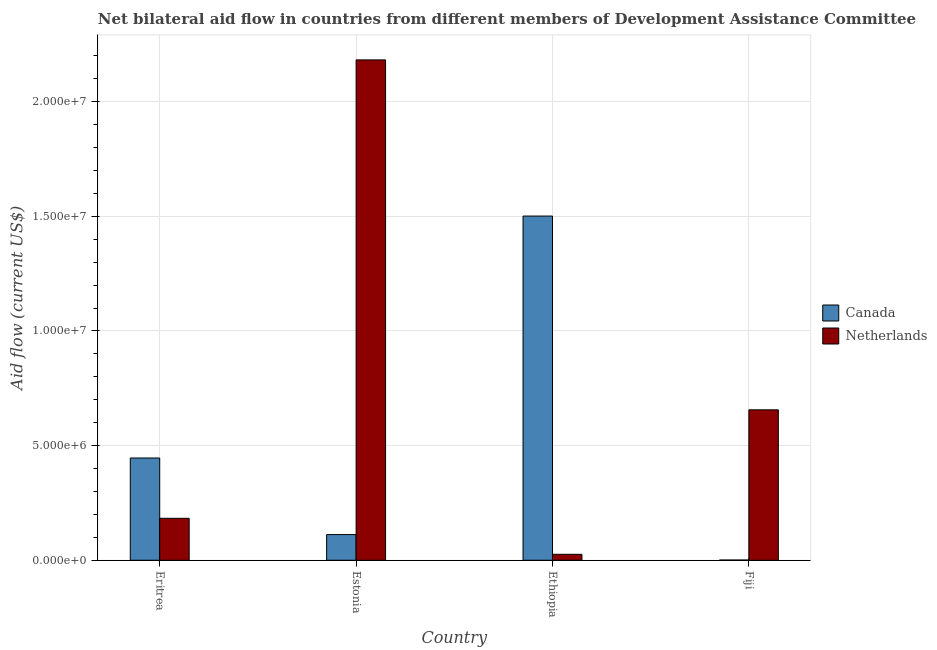How many different coloured bars are there?
Provide a succinct answer. 2. Are the number of bars per tick equal to the number of legend labels?
Your answer should be compact. Yes. How many bars are there on the 2nd tick from the left?
Your response must be concise. 2. How many bars are there on the 4th tick from the right?
Your answer should be very brief. 2. What is the label of the 4th group of bars from the left?
Keep it short and to the point. Fiji. What is the amount of aid given by netherlands in Ethiopia?
Keep it short and to the point. 2.60e+05. Across all countries, what is the maximum amount of aid given by canada?
Offer a terse response. 1.50e+07. Across all countries, what is the minimum amount of aid given by canada?
Your answer should be very brief. 10000. In which country was the amount of aid given by netherlands maximum?
Make the answer very short. Estonia. In which country was the amount of aid given by netherlands minimum?
Provide a succinct answer. Ethiopia. What is the total amount of aid given by netherlands in the graph?
Your answer should be very brief. 3.05e+07. What is the difference between the amount of aid given by netherlands in Estonia and that in Ethiopia?
Ensure brevity in your answer.  2.16e+07. What is the difference between the amount of aid given by netherlands in Estonia and the amount of aid given by canada in Eritrea?
Give a very brief answer. 1.74e+07. What is the average amount of aid given by canada per country?
Your answer should be very brief. 5.15e+06. What is the difference between the amount of aid given by canada and amount of aid given by netherlands in Ethiopia?
Ensure brevity in your answer.  1.48e+07. What is the ratio of the amount of aid given by netherlands in Estonia to that in Fiji?
Provide a short and direct response. 3.33. Is the amount of aid given by netherlands in Eritrea less than that in Ethiopia?
Your response must be concise. No. What is the difference between the highest and the second highest amount of aid given by canada?
Make the answer very short. 1.06e+07. What is the difference between the highest and the lowest amount of aid given by canada?
Provide a succinct answer. 1.50e+07. In how many countries, is the amount of aid given by canada greater than the average amount of aid given by canada taken over all countries?
Keep it short and to the point. 1. Is the sum of the amount of aid given by canada in Eritrea and Ethiopia greater than the maximum amount of aid given by netherlands across all countries?
Keep it short and to the point. No. What does the 1st bar from the left in Eritrea represents?
Offer a terse response. Canada. What does the 2nd bar from the right in Eritrea represents?
Your answer should be compact. Canada. How many bars are there?
Your answer should be very brief. 8. What is the difference between two consecutive major ticks on the Y-axis?
Ensure brevity in your answer.  5.00e+06. How many legend labels are there?
Make the answer very short. 2. How are the legend labels stacked?
Ensure brevity in your answer.  Vertical. What is the title of the graph?
Keep it short and to the point. Net bilateral aid flow in countries from different members of Development Assistance Committee. What is the label or title of the X-axis?
Keep it short and to the point. Country. What is the Aid flow (current US$) in Canada in Eritrea?
Provide a short and direct response. 4.46e+06. What is the Aid flow (current US$) of Netherlands in Eritrea?
Your answer should be compact. 1.83e+06. What is the Aid flow (current US$) of Canada in Estonia?
Your answer should be very brief. 1.12e+06. What is the Aid flow (current US$) of Netherlands in Estonia?
Your answer should be very brief. 2.18e+07. What is the Aid flow (current US$) in Canada in Ethiopia?
Offer a terse response. 1.50e+07. What is the Aid flow (current US$) in Netherlands in Ethiopia?
Your response must be concise. 2.60e+05. What is the Aid flow (current US$) of Netherlands in Fiji?
Your response must be concise. 6.56e+06. Across all countries, what is the maximum Aid flow (current US$) of Canada?
Make the answer very short. 1.50e+07. Across all countries, what is the maximum Aid flow (current US$) of Netherlands?
Provide a short and direct response. 2.18e+07. Across all countries, what is the minimum Aid flow (current US$) of Canada?
Keep it short and to the point. 10000. Across all countries, what is the minimum Aid flow (current US$) of Netherlands?
Provide a short and direct response. 2.60e+05. What is the total Aid flow (current US$) in Canada in the graph?
Your response must be concise. 2.06e+07. What is the total Aid flow (current US$) in Netherlands in the graph?
Offer a very short reply. 3.05e+07. What is the difference between the Aid flow (current US$) in Canada in Eritrea and that in Estonia?
Provide a short and direct response. 3.34e+06. What is the difference between the Aid flow (current US$) of Netherlands in Eritrea and that in Estonia?
Give a very brief answer. -2.00e+07. What is the difference between the Aid flow (current US$) in Canada in Eritrea and that in Ethiopia?
Keep it short and to the point. -1.06e+07. What is the difference between the Aid flow (current US$) of Netherlands in Eritrea and that in Ethiopia?
Offer a terse response. 1.57e+06. What is the difference between the Aid flow (current US$) in Canada in Eritrea and that in Fiji?
Keep it short and to the point. 4.45e+06. What is the difference between the Aid flow (current US$) in Netherlands in Eritrea and that in Fiji?
Give a very brief answer. -4.73e+06. What is the difference between the Aid flow (current US$) of Canada in Estonia and that in Ethiopia?
Your answer should be very brief. -1.39e+07. What is the difference between the Aid flow (current US$) in Netherlands in Estonia and that in Ethiopia?
Make the answer very short. 2.16e+07. What is the difference between the Aid flow (current US$) in Canada in Estonia and that in Fiji?
Keep it short and to the point. 1.11e+06. What is the difference between the Aid flow (current US$) of Netherlands in Estonia and that in Fiji?
Your answer should be compact. 1.53e+07. What is the difference between the Aid flow (current US$) of Canada in Ethiopia and that in Fiji?
Provide a short and direct response. 1.50e+07. What is the difference between the Aid flow (current US$) of Netherlands in Ethiopia and that in Fiji?
Offer a very short reply. -6.30e+06. What is the difference between the Aid flow (current US$) in Canada in Eritrea and the Aid flow (current US$) in Netherlands in Estonia?
Provide a short and direct response. -1.74e+07. What is the difference between the Aid flow (current US$) in Canada in Eritrea and the Aid flow (current US$) in Netherlands in Ethiopia?
Your answer should be compact. 4.20e+06. What is the difference between the Aid flow (current US$) in Canada in Eritrea and the Aid flow (current US$) in Netherlands in Fiji?
Offer a terse response. -2.10e+06. What is the difference between the Aid flow (current US$) of Canada in Estonia and the Aid flow (current US$) of Netherlands in Ethiopia?
Provide a succinct answer. 8.60e+05. What is the difference between the Aid flow (current US$) of Canada in Estonia and the Aid flow (current US$) of Netherlands in Fiji?
Your response must be concise. -5.44e+06. What is the difference between the Aid flow (current US$) of Canada in Ethiopia and the Aid flow (current US$) of Netherlands in Fiji?
Make the answer very short. 8.45e+06. What is the average Aid flow (current US$) of Canada per country?
Offer a terse response. 5.15e+06. What is the average Aid flow (current US$) of Netherlands per country?
Offer a very short reply. 7.62e+06. What is the difference between the Aid flow (current US$) in Canada and Aid flow (current US$) in Netherlands in Eritrea?
Your answer should be compact. 2.63e+06. What is the difference between the Aid flow (current US$) in Canada and Aid flow (current US$) in Netherlands in Estonia?
Your response must be concise. -2.07e+07. What is the difference between the Aid flow (current US$) in Canada and Aid flow (current US$) in Netherlands in Ethiopia?
Your answer should be compact. 1.48e+07. What is the difference between the Aid flow (current US$) in Canada and Aid flow (current US$) in Netherlands in Fiji?
Offer a very short reply. -6.55e+06. What is the ratio of the Aid flow (current US$) of Canada in Eritrea to that in Estonia?
Make the answer very short. 3.98. What is the ratio of the Aid flow (current US$) in Netherlands in Eritrea to that in Estonia?
Provide a succinct answer. 0.08. What is the ratio of the Aid flow (current US$) of Canada in Eritrea to that in Ethiopia?
Provide a succinct answer. 0.3. What is the ratio of the Aid flow (current US$) in Netherlands in Eritrea to that in Ethiopia?
Give a very brief answer. 7.04. What is the ratio of the Aid flow (current US$) in Canada in Eritrea to that in Fiji?
Your answer should be very brief. 446. What is the ratio of the Aid flow (current US$) in Netherlands in Eritrea to that in Fiji?
Offer a terse response. 0.28. What is the ratio of the Aid flow (current US$) of Canada in Estonia to that in Ethiopia?
Provide a succinct answer. 0.07. What is the ratio of the Aid flow (current US$) of Netherlands in Estonia to that in Ethiopia?
Ensure brevity in your answer.  83.92. What is the ratio of the Aid flow (current US$) of Canada in Estonia to that in Fiji?
Your response must be concise. 112. What is the ratio of the Aid flow (current US$) of Netherlands in Estonia to that in Fiji?
Give a very brief answer. 3.33. What is the ratio of the Aid flow (current US$) in Canada in Ethiopia to that in Fiji?
Provide a short and direct response. 1501. What is the ratio of the Aid flow (current US$) of Netherlands in Ethiopia to that in Fiji?
Your answer should be very brief. 0.04. What is the difference between the highest and the second highest Aid flow (current US$) in Canada?
Provide a succinct answer. 1.06e+07. What is the difference between the highest and the second highest Aid flow (current US$) of Netherlands?
Your answer should be very brief. 1.53e+07. What is the difference between the highest and the lowest Aid flow (current US$) of Canada?
Your response must be concise. 1.50e+07. What is the difference between the highest and the lowest Aid flow (current US$) in Netherlands?
Provide a short and direct response. 2.16e+07. 